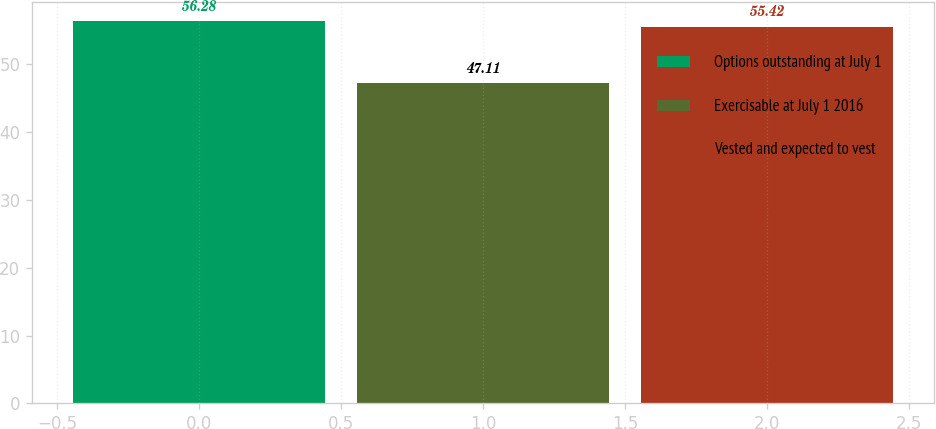Convert chart to OTSL. <chart><loc_0><loc_0><loc_500><loc_500><bar_chart><fcel>Options outstanding at July 1<fcel>Exercisable at July 1 2016<fcel>Vested and expected to vest<nl><fcel>56.28<fcel>47.11<fcel>55.42<nl></chart> 